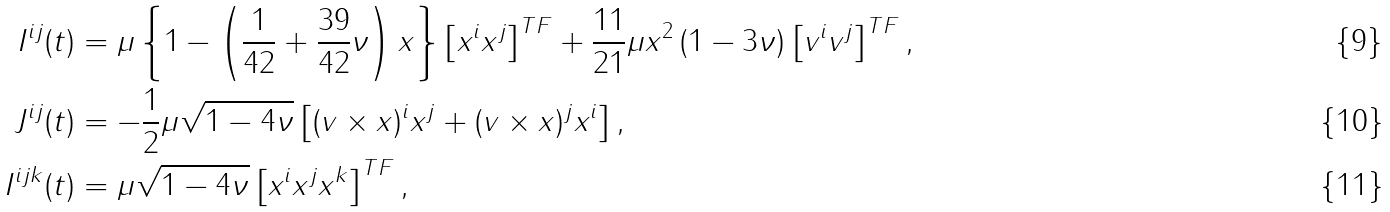<formula> <loc_0><loc_0><loc_500><loc_500>I ^ { i j } ( t ) & = \mu \left \{ 1 - \left ( \frac { 1 } { 4 2 } + \frac { 3 9 } { 4 2 } \nu \right ) x \right \} \left [ { x } ^ { i } { x } ^ { j } \right ] ^ { T F } + \frac { 1 1 } { 2 1 } \mu { x } ^ { 2 } \left ( 1 - 3 \nu \right ) \left [ { v } ^ { i } { v } ^ { j } \right ] ^ { T F } , \\ J ^ { i j } ( t ) & = - \frac { 1 } { 2 } \mu \sqrt { 1 - 4 \nu } \left [ ( { v } \times { x } ) ^ { i } { x } ^ { j } + ( { v } \times { x } ) ^ { j } { x } ^ { i } \right ] , \\ I ^ { i j k } ( t ) & = \mu \sqrt { 1 - 4 \nu } \left [ { x } ^ { i } { x } ^ { j } { x } ^ { k } \right ] ^ { T F } ,</formula> 